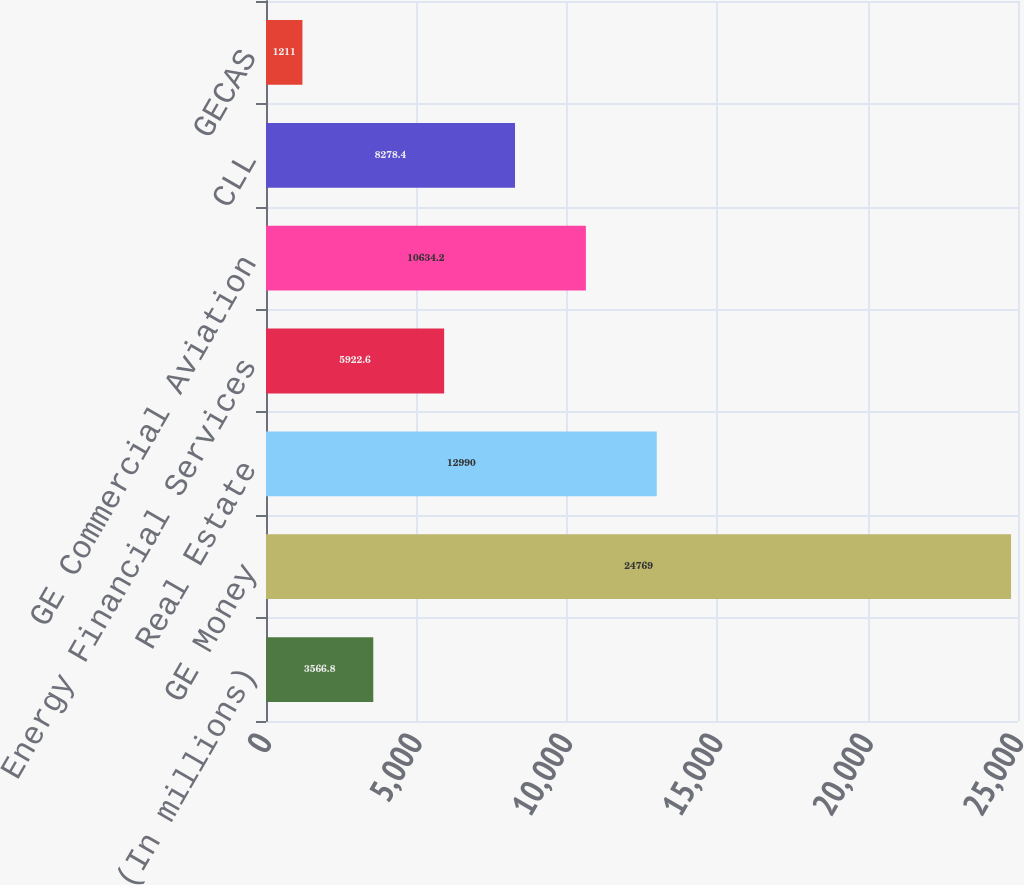<chart> <loc_0><loc_0><loc_500><loc_500><bar_chart><fcel>(In millions)<fcel>GE Money<fcel>Real Estate<fcel>Energy Financial Services<fcel>GE Commercial Aviation<fcel>CLL<fcel>GECAS<nl><fcel>3566.8<fcel>24769<fcel>12990<fcel>5922.6<fcel>10634.2<fcel>8278.4<fcel>1211<nl></chart> 